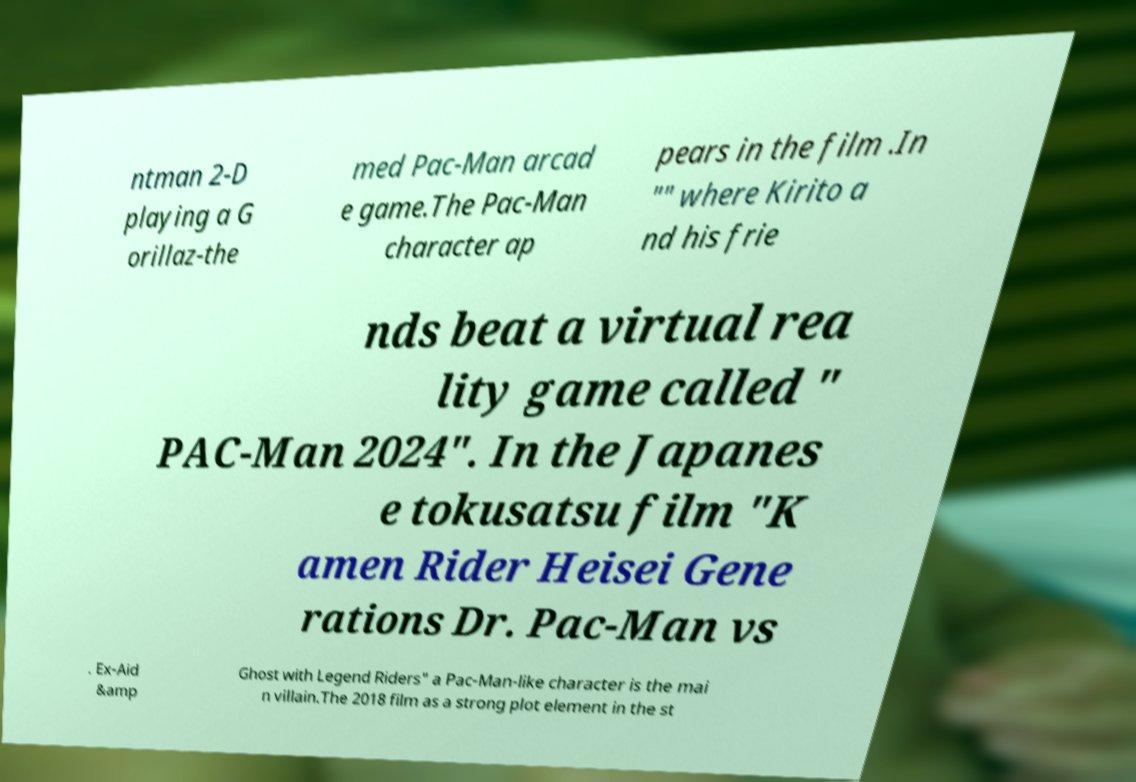Can you accurately transcribe the text from the provided image for me? ntman 2-D playing a G orillaz-the med Pac-Man arcad e game.The Pac-Man character ap pears in the film .In "" where Kirito a nd his frie nds beat a virtual rea lity game called " PAC-Man 2024". In the Japanes e tokusatsu film "K amen Rider Heisei Gene rations Dr. Pac-Man vs . Ex-Aid &amp Ghost with Legend Riders" a Pac-Man-like character is the mai n villain.The 2018 film as a strong plot element in the st 